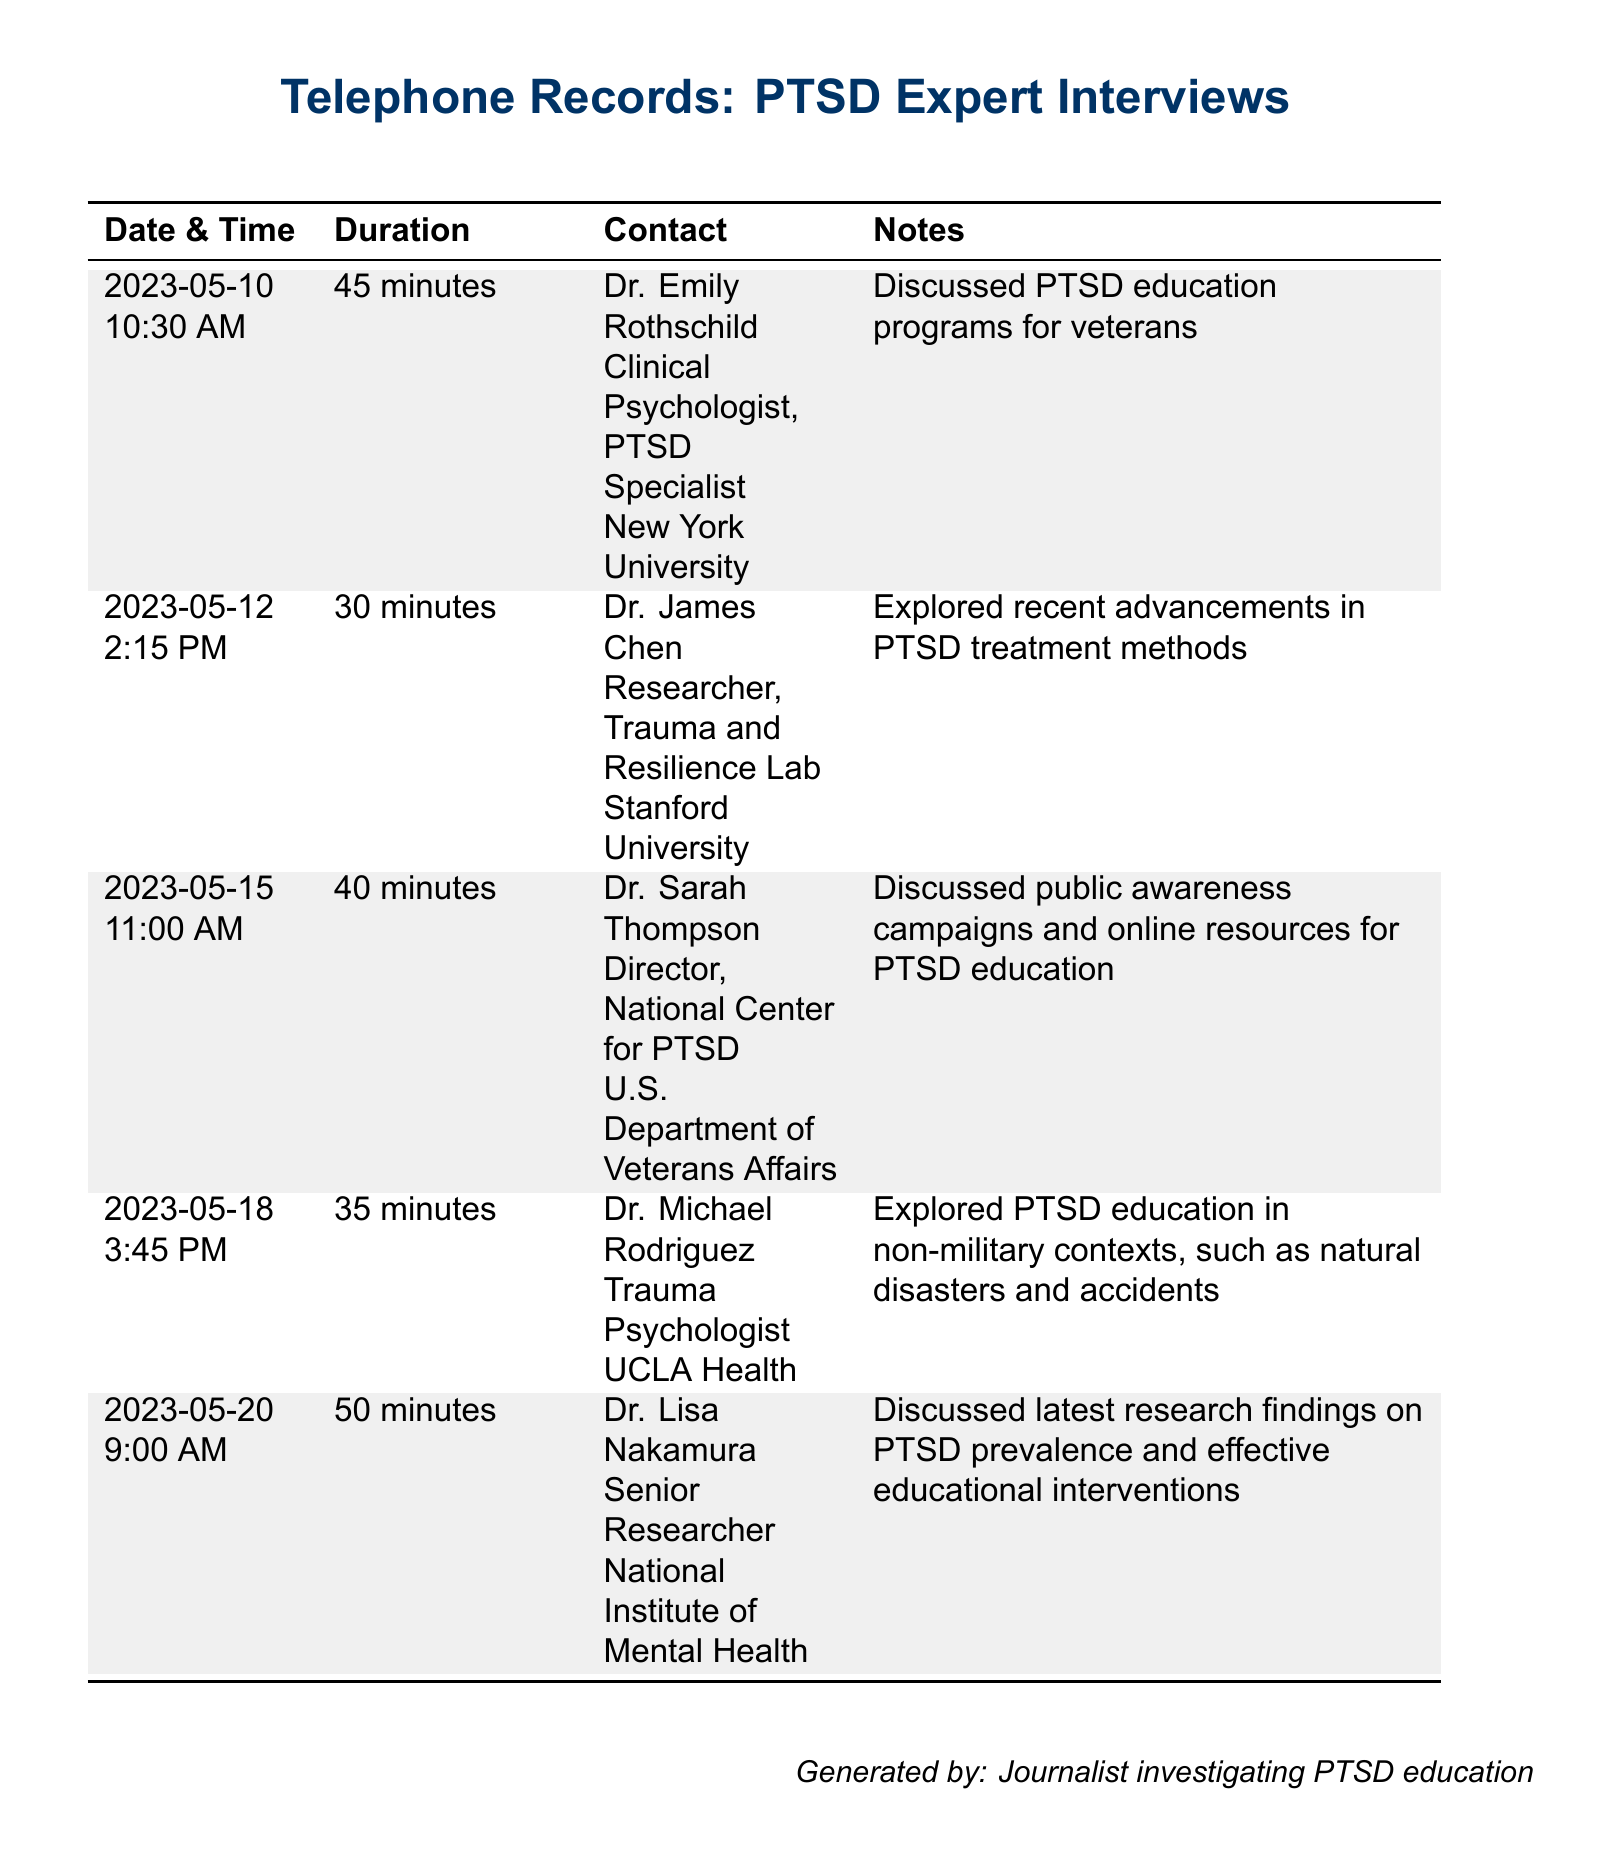What is the date of the first interview? The first interview took place on May 10, 2023.
Answer: May 10, 2023 Who conducted the interview on May 12? The interview on May 12 was conducted by Dr. James Chen.
Answer: Dr. James Chen How long was the interview with Dr. Michael Rodriguez? The interview with Dr. Michael Rodriguez lasted for 35 minutes.
Answer: 35 minutes What is the primary focus of Dr. Sarah Thompson's work? Dr. Sarah Thompson is focused on public awareness campaigns and online resources for PTSD education.
Answer: Public awareness campaigns and online resources How many minutes did Dr. Lisa Nakamura speak about PTSD research? Dr. Lisa Nakamura spoke for 50 minutes about PTSD research findings.
Answer: 50 minutes Which institution is Dr. Emily Rothschild affiliated with? Dr. Emily Rothschild is affiliated with New York University.
Answer: New York University What type of psychologist is Dr. Michael Rodriguez? Dr. Michael Rodriguez is a trauma psychologist.
Answer: Trauma Psychologist What is the contact method used for these records? The records indicate that the contact method is telephone interviews.
Answer: Telephone interviews 